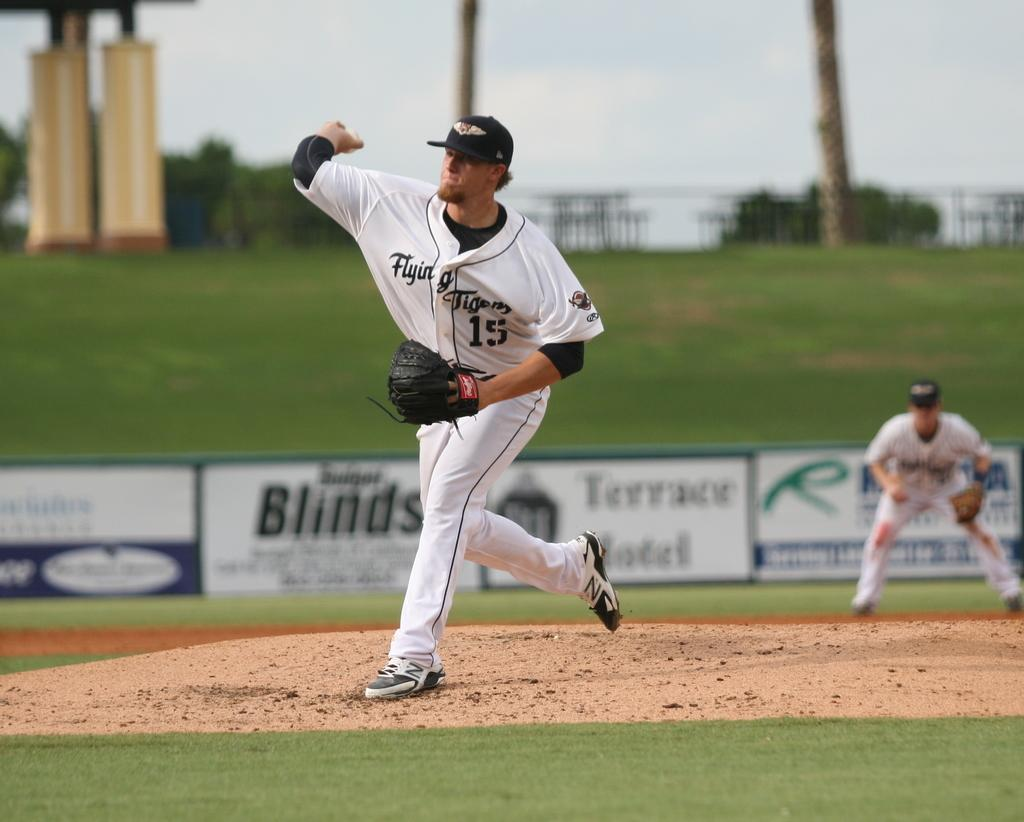<image>
Create a compact narrative representing the image presented. Player number 15 is about to throw the baseball. 